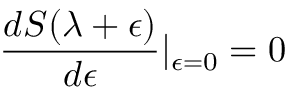<formula> <loc_0><loc_0><loc_500><loc_500>\frac { d S ( \lambda + \epsilon ) } { d \epsilon } | _ { \epsilon = 0 } = 0</formula> 